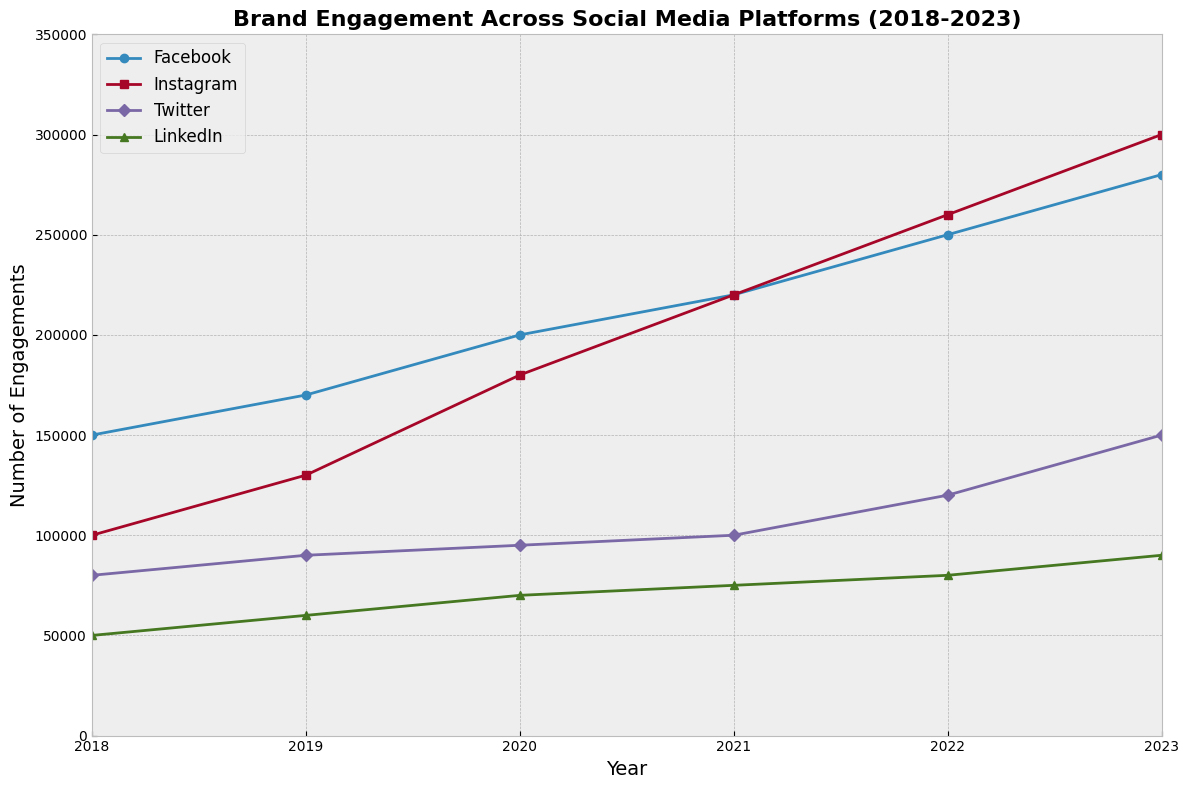Which social media platform showed the most significant increase in engagements from 2018 to 2023? To determine which platform experienced the most significant increase, subtract the number of engagements in 2018 from the number in 2023 for each platform. Facebook: 280,000 - 150,000 = 130,000. Instagram: 300,000 - 100,000 = 200,000. Twitter: 150,000 - 80,000 = 70,000. LinkedIn: 90,000 - 50,000 = 40,000. Comparing these, Instagram shows the largest increase of 200,000.
Answer: Instagram What is the total engagement across all platforms in 2023? To find the total engagement in 2023, sum the number of engagements for all four platforms in that year. Engagements: Facebook (280,000) + Instagram (300,000) + Twitter (150,000) + LinkedIn (90,000) = 820,000.
Answer: 820,000 Between which two successive years did Instagram see the largest year-over-year increase in engagements? To find this, calculate the year-over-year increase for Instagram and compare. 2019-2018: 130,000 - 100,000 = 30,000. 2020-2019: 180,000 - 130,000 = 50,000. 2021-2020: 220,000 - 180,000 = 40,000. 2022-2021: 260,000 - 220,000 = 40,000. 2023-2022: 300,000 - 260,000 = 40,000. The largest increase of 50,000 occurred between 2019 and 2020.
Answer: 2019-2020 By how much did Twitter's engagement increase from 2020 to 2023? To find the increase, subtract Twitter's engagements in 2020 from those in 2023. Twitter 2023: 150,000. Twitter 2020: 95,000. 150,000 - 95,000 = 55,000.
Answer: 55,000 Which platform had the lowest total engagement over the 5-year span from 2018 to 2023? Calculate the total engagements for each platform over the five years and compare. Facebook: 150,000 + 170,000 + 200,000 + 220,000 + 250,000 + 280,000 = 1,270,000. Instagram: 100,000 + 130,000 + 180,000 + 220,000 + 260,000 + 300,000 = 1,190,000. Twitter: 80,000 + 90,000 + 95,000 + 100,000 + 120,000 + 150,000 = 635,000. LinkedIn: 50,000 + 60,000 + 70,000 + 75,000 + 80,000 + 90,000 = 425,000. LinkedIn has the lowest total engagement of 425,000.
Answer: LinkedIn What is the average annual engagement for Facebook from 2018 to 2023? Find the total engagement for Facebook over six years and divide by 6. Facebook engagement over the years: 150,000 + 170,000 + 200,000 + 220,000 + 250,000 + 280,000 = 1,270,000. Average: 1,270,000 / 6 ≈ 211,667.
Answer: 211,667 Which year saw LinkedIn's highest number of engagements? Look at the engagement numbers for LinkedIn each year and identify the highest. LinkedIn's engagements are: 50,000 (2018), 60,000 (2019), 70,000 (2020), 75,000 (2021), 80,000 (2022), 90,000 (2023). The highest engagement, 90,000, occurred in 2023.
Answer: 2023 Compare the engagement trend of Facebook and Twitter. Which one showed a steadier increase overall? Visually inspect the figure to compare the engagement trends of Facebook and Twitter. Facebook shows a steady increase year-over-year with no drops. Twitter, although increasing, had relatively smaller and less consistent increases. Therefore, Facebook shows a steadier increase overall.
Answer: Facebook 